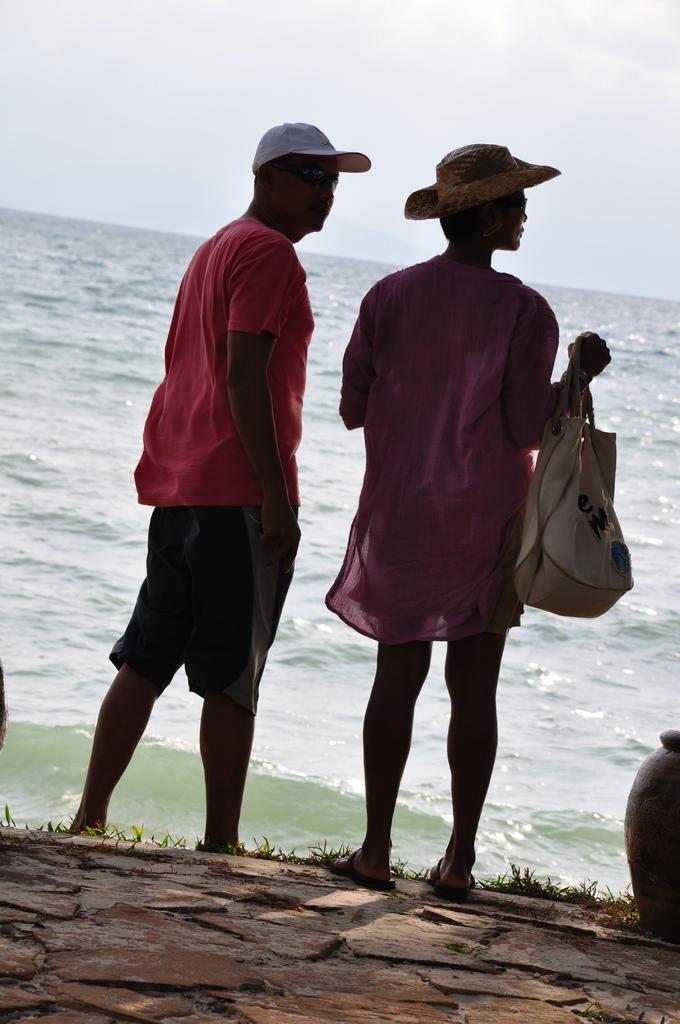How many people are in the image? There are two persons in the image. What are the persons wearing on their heads? Both persons are wearing caps. What is one person holding in the image? One person is holding a bag. What can be seen in the background of the image? Water and the sky are visible in the background of the image. What type of loaf is the scarecrow singing in the image? There is no loaf or scarecrow present in the image, and no one is singing. 